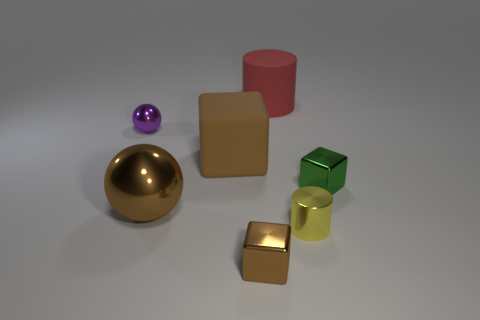Subtract all large blocks. How many blocks are left? 2 Add 1 brown metal balls. How many objects exist? 8 Subtract all green cubes. How many cubes are left? 2 Subtract 1 spheres. How many spheres are left? 1 Subtract all spheres. How many objects are left? 5 Subtract all blue cylinders. Subtract all red cubes. How many cylinders are left? 2 Subtract all green cubes. How many brown spheres are left? 1 Subtract all metallic objects. Subtract all yellow shiny things. How many objects are left? 1 Add 6 red matte cylinders. How many red matte cylinders are left? 7 Add 2 tiny gray metal spheres. How many tiny gray metal spheres exist? 2 